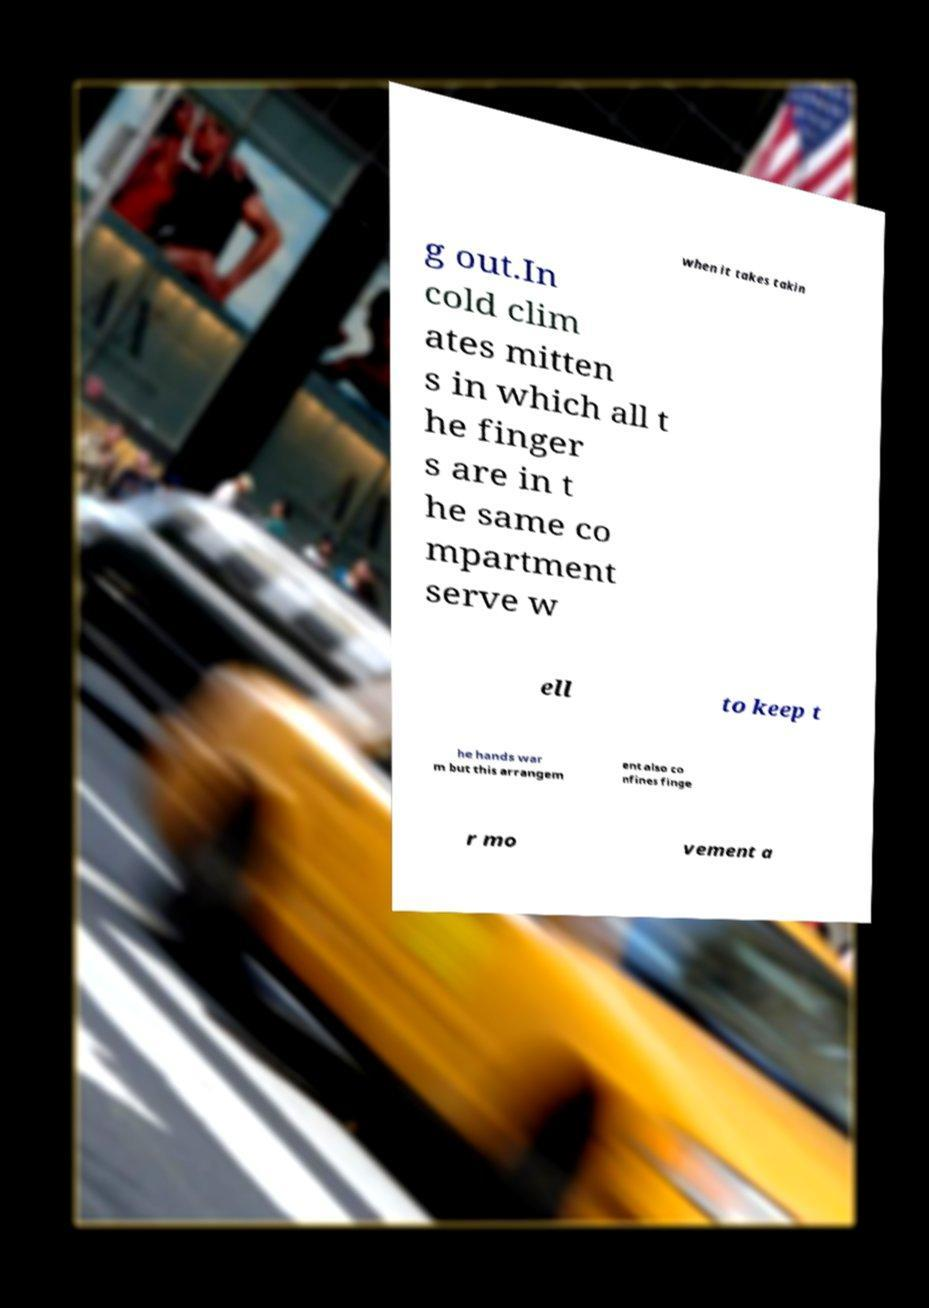Can you accurately transcribe the text from the provided image for me? when it takes takin g out.In cold clim ates mitten s in which all t he finger s are in t he same co mpartment serve w ell to keep t he hands war m but this arrangem ent also co nfines finge r mo vement a 